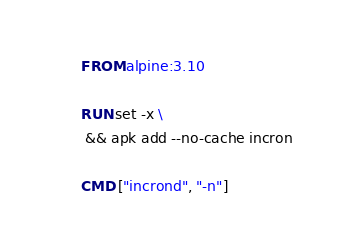<code> <loc_0><loc_0><loc_500><loc_500><_Dockerfile_>FROM alpine:3.10

RUN set -x \
 && apk add --no-cache incron

CMD ["incrond", "-n"]
</code> 